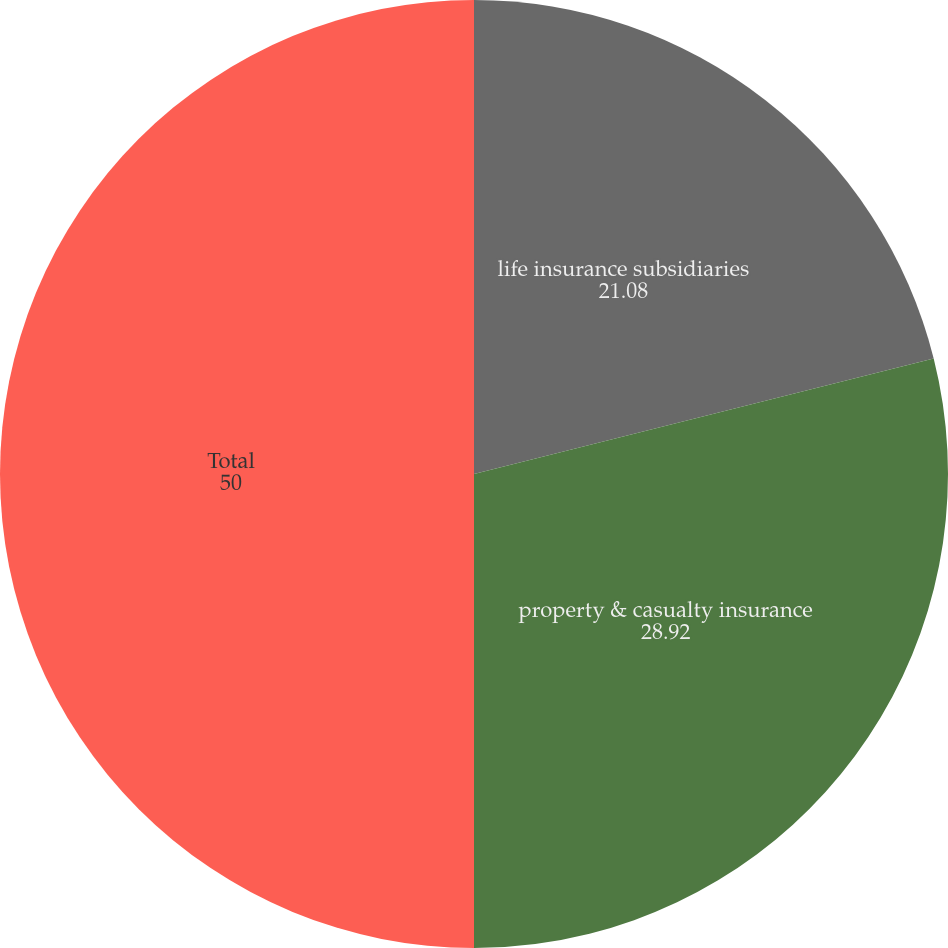Convert chart. <chart><loc_0><loc_0><loc_500><loc_500><pie_chart><fcel>life insurance subsidiaries<fcel>property & casualty insurance<fcel>Total<nl><fcel>21.08%<fcel>28.92%<fcel>50.0%<nl></chart> 